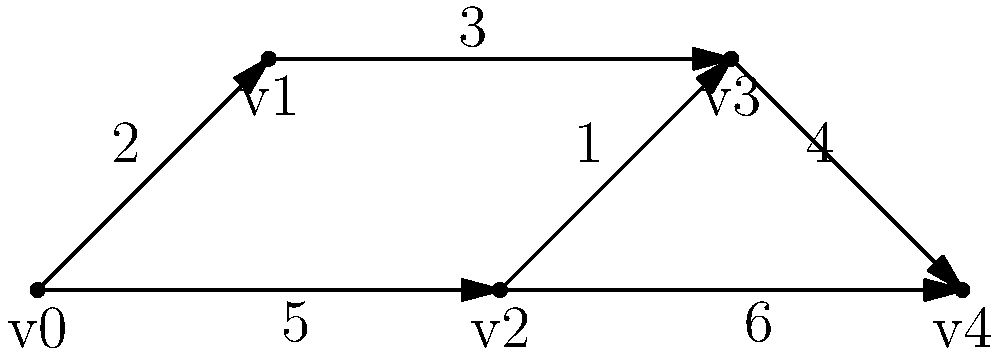Given the network topology represented by the directed graph above, where each edge is labeled with its corresponding transmission time (in milliseconds), what is the shortest path from node v0 to node v4, and what is its total transmission time? To find the shortest path from v0 to v4, we can use Dijkstra's algorithm, which is an efficient graph traversal technique for finding the shortest path in a weighted graph. Let's apply the algorithm step-by-step:

1. Initialize:
   - Set distance to v0 as 0, and all other nodes as infinity.
   - Set all nodes as unvisited.

2. Start from v0:
   - Update distances to neighbors:
     v1: 2 ms
     v2: 5 ms

3. Select the node with the smallest distance (v1) and mark it as visited:
   - Update distances through v1:
     v3: 2 + 3 = 5 ms

4. Select the next smallest distance (v2) and mark it as visited:
   - Update distances through v2:
     v3: min(5, 5 + 1) = 5 ms (no change)
     v4: 5 + 6 = 11 ms

5. Select the next smallest distance (v3) and mark it as visited:
   - Update distances through v3:
     v4: min(11, 5 + 4) = 9 ms

6. Select v4 (the destination) as it has the smallest distance among unvisited nodes.

The shortest path is v0 -> v1 -> v3 -> v4, with a total transmission time of 9 ms.
Answer: v0 -> v1 -> v3 -> v4; 9 ms 